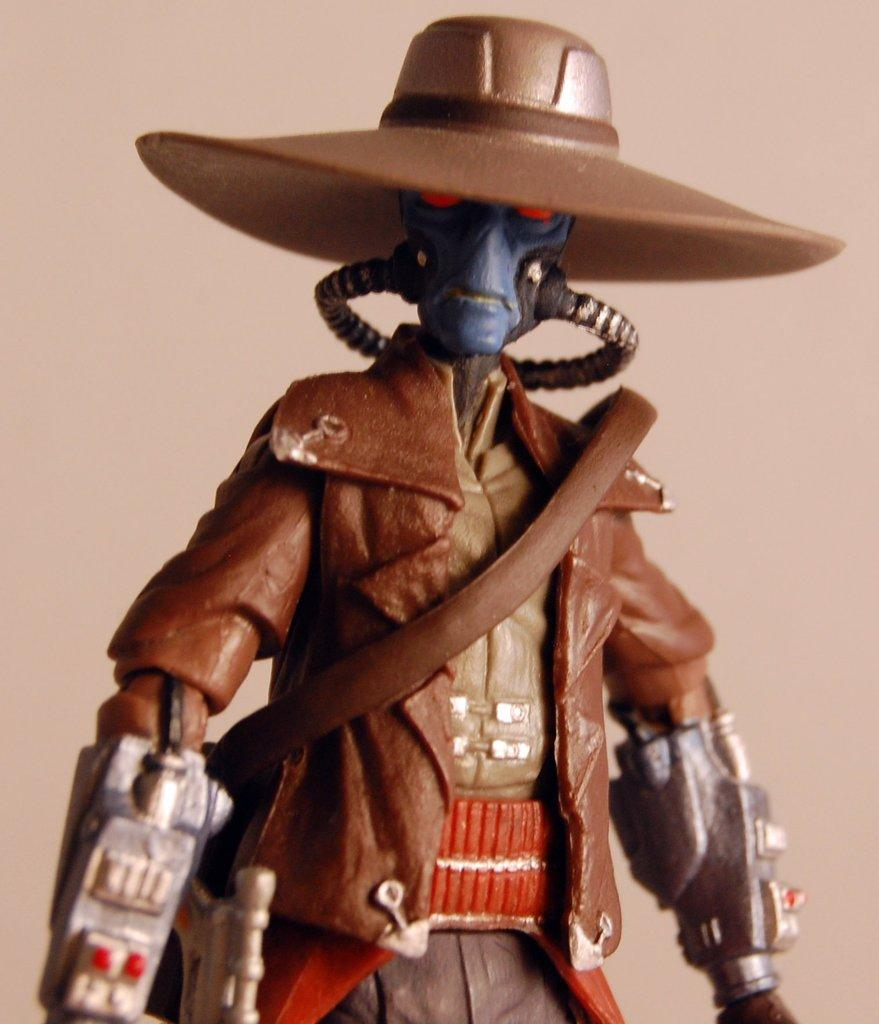What is the main subject of the image? There is a statue of a person in the image. What is the person holding in the statue? The person is holding a gun. What type of headwear is the person wearing in the statue? The person is wearing a cap. What color is the background of the image? The background of the image is cream in color. Can you see any silver items in the person's pocket in the image? There is no pocket or silver items present in the image, as it features a statue of a person holding a gun and wearing a cap. 